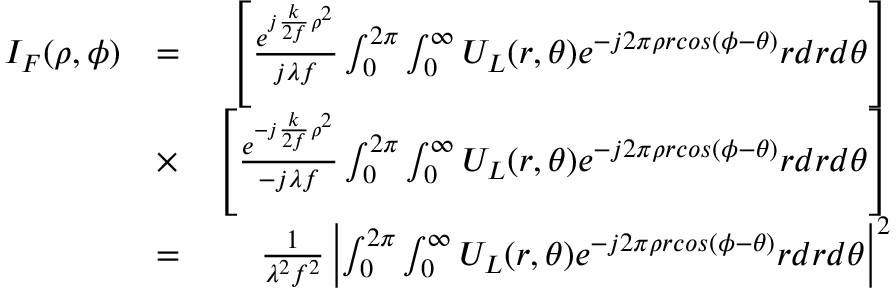<formula> <loc_0><loc_0><loc_500><loc_500>\begin{array} { r l r } { I _ { F } ( \rho , \phi ) } & { = } & { \left [ \frac { e ^ { j \frac { k } { 2 f } \rho ^ { 2 } } } { j \lambda f } \int _ { 0 } ^ { 2 \pi } \int _ { 0 } ^ { \infty } U _ { L } ( r , \theta ) e ^ { - j 2 \pi \rho r \cos ( \phi - \theta ) } r d r d \theta \right ] } \\ & { \times } & { \left [ \frac { e ^ { - j \frac { k } { 2 f } \rho ^ { 2 } } } { - j \lambda f } \int _ { 0 } ^ { 2 \pi } \int _ { 0 } ^ { \infty } U _ { L } ( r , \theta ) e ^ { - j 2 \pi \rho r \cos ( \phi - \theta ) } r d r d \theta \right ] } \\ & { = } & { \frac { 1 } { \lambda ^ { 2 } f ^ { 2 } } \left | \int _ { 0 } ^ { 2 \pi } \int _ { 0 } ^ { \infty } U _ { L } ( r , \theta ) e ^ { - j 2 \pi \rho r \cos ( \phi - \theta ) } r d r d \theta \right | ^ { 2 } } \end{array}</formula> 